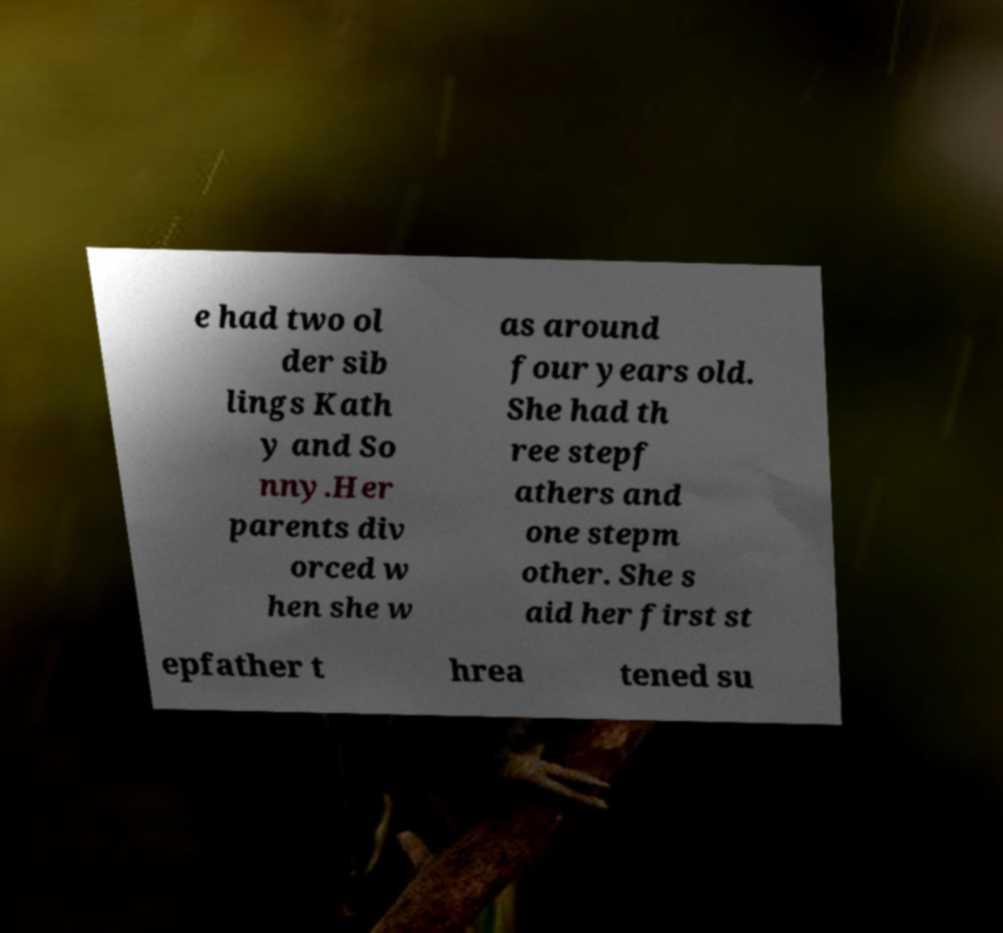Please read and relay the text visible in this image. What does it say? e had two ol der sib lings Kath y and So nny.Her parents div orced w hen she w as around four years old. She had th ree stepf athers and one stepm other. She s aid her first st epfather t hrea tened su 